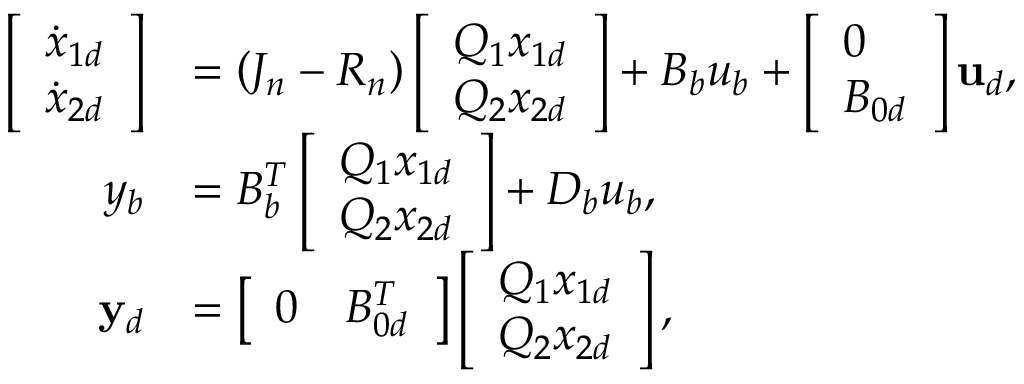Convert formula to latex. <formula><loc_0><loc_0><loc_500><loc_500>\begin{array} { r l } { \left [ \begin{array} { l } { \dot { x } _ { 1 d } } \\ { \dot { x } _ { 2 d } } \end{array} \right ] } & { = \left ( J _ { n } - R _ { n } \right ) \left [ \begin{array} { l } { Q _ { 1 } x _ { 1 d } } \\ { Q _ { 2 } x _ { 2 d } } \end{array} \right ] + B _ { b } u _ { b } + \left [ \begin{array} { l } { 0 } \\ { B _ { 0 d } } \end{array} \right ] u _ { d } , } \\ { y _ { b } } & { = B _ { b } ^ { T } \left [ \begin{array} { l } { Q _ { 1 } x _ { 1 d } } \\ { Q _ { 2 } x _ { 2 d } } \end{array} \right ] + D _ { b } u _ { b } , } \\ { y _ { d } } & { = \left [ \begin{array} { l l } { 0 } & { B _ { 0 d } ^ { T } } \end{array} \right ] \left [ \begin{array} { l } { Q _ { 1 } x _ { 1 d } } \\ { Q _ { 2 } x _ { 2 d } } \end{array} \right ] , } \end{array}</formula> 